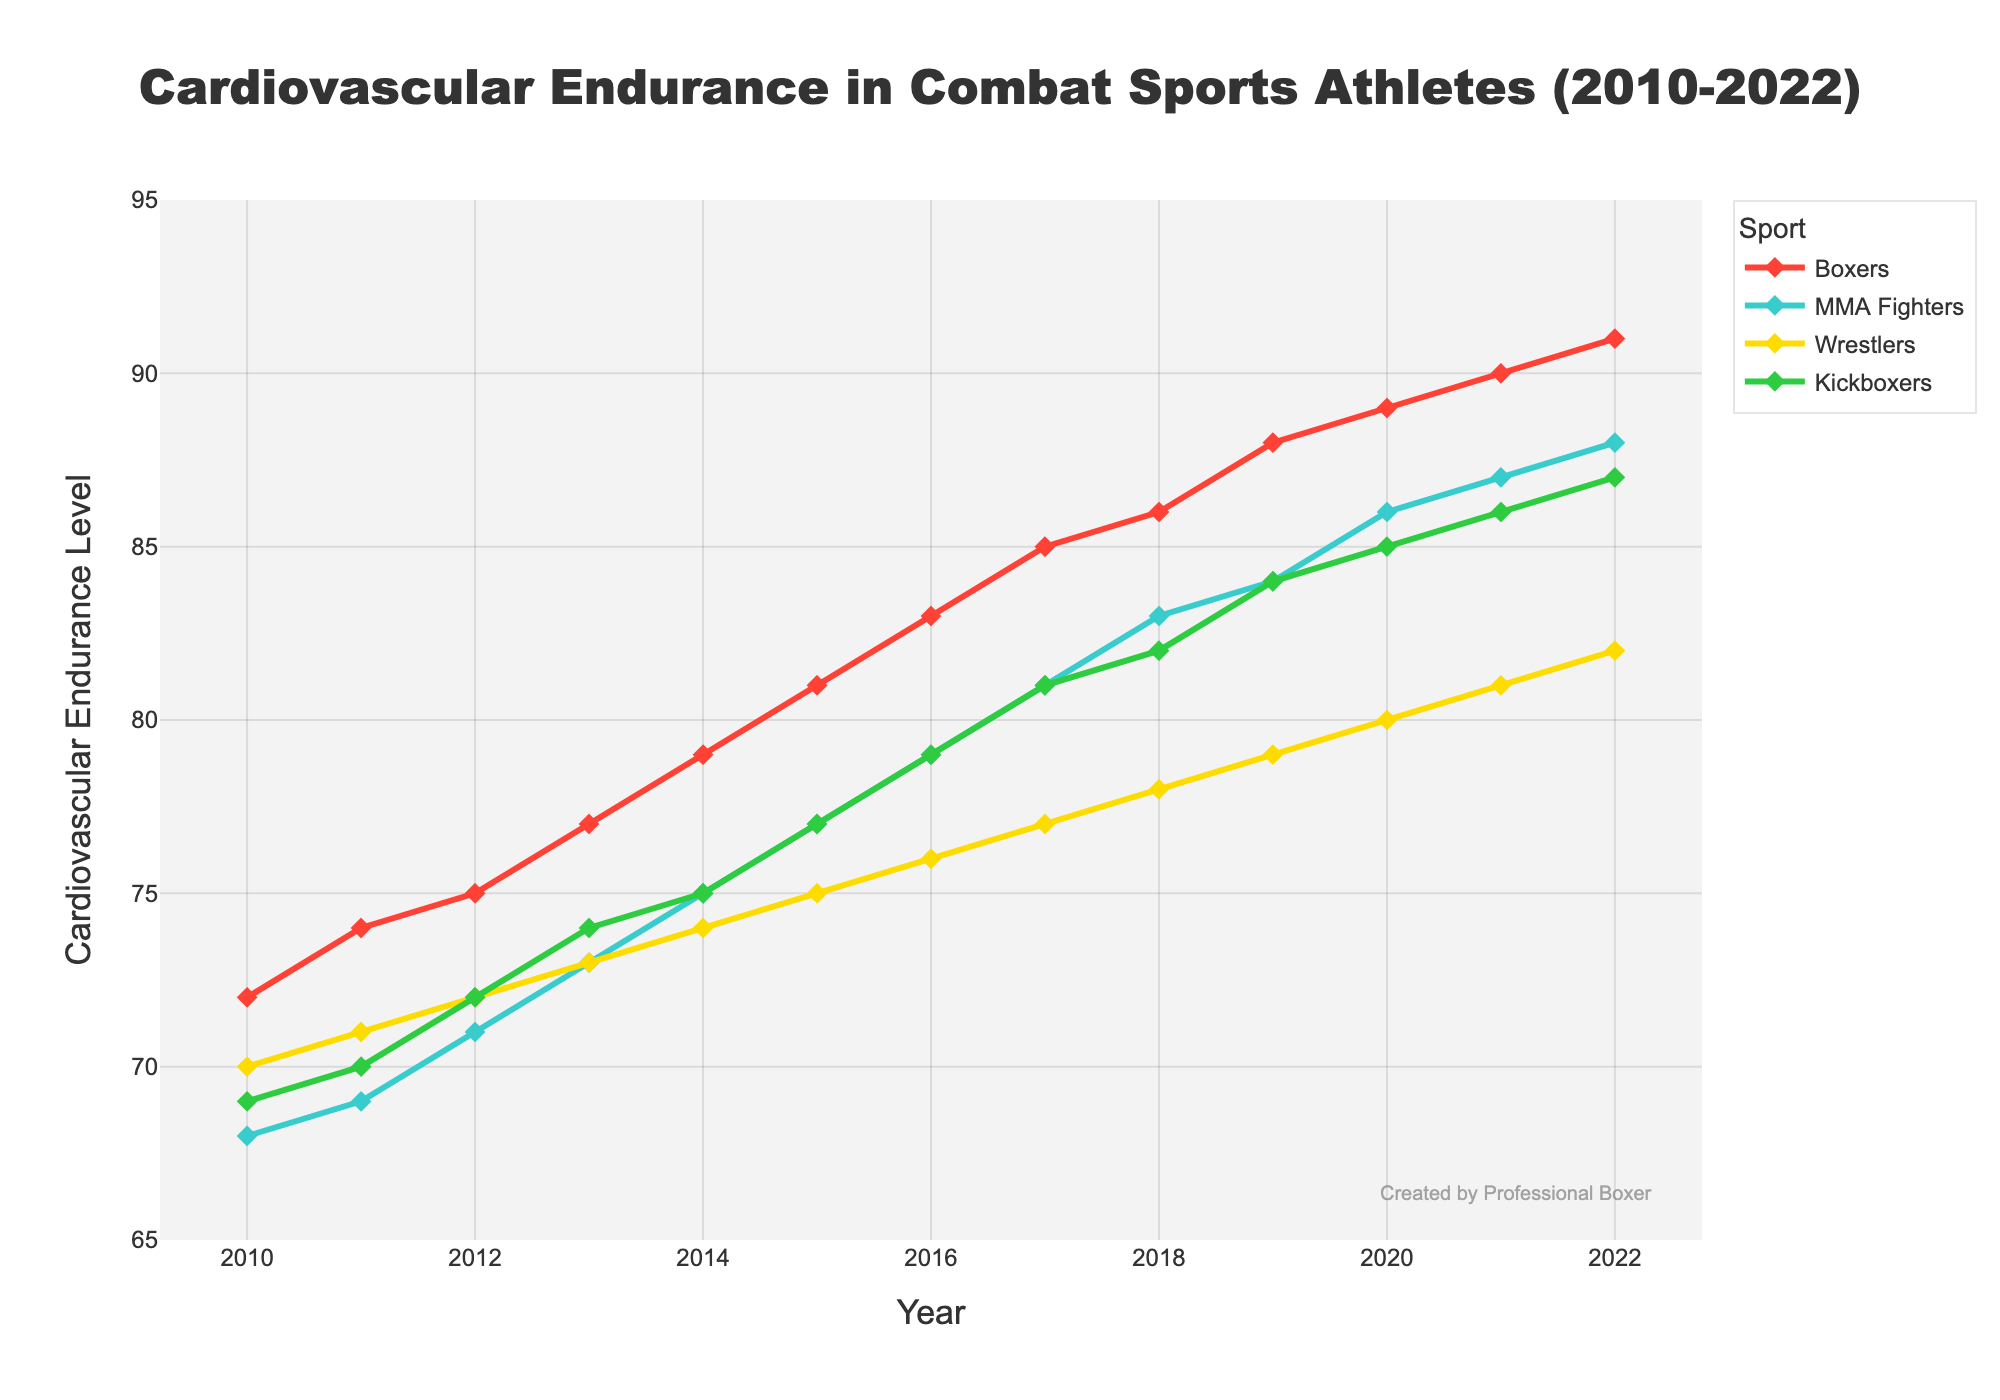Which sport has the highest cardiovascular endurance level in 2022? By looking at the figure, the trace representing Boxers reaches the highest peak at 2022 with a value of 91 compared to other sports.
Answer: Boxers How does the cardiovascular endurance level of MMA Fighters in 2015 compare to Kickboxers in the same year? In the figure, the mark for MMA Fighters in 2015 is at 77, while Kickboxers are at 77. Both values are equal.
Answer: Equal What is the difference in cardiovascular endurance levels between Boxers and Wrestlers in 2020? From the 2020 data points, Boxers are at a level of 89, and Wrestlers are at 80. The difference between them is 89 - 80 = 9.
Answer: 9 Which sport has shown the largest increase in cardiovascular endurance levels from 2010 to 2022? By comparing the starting point (2010) and ending point (2022) of each trace, Boxers went from 72 to 91, increasing by 19 points, the largest among all the sports.
Answer: Boxers On average, how did the cardiovascular endurance levels of Kickboxers change from 2010 to 2022? Averaging the cardiovascular endurance levels of Kickboxers from 2010 to 2022: (69 + 70 + 72 + 74 + 75 + 77 + 79 + 81 + 82 + 84 + 85 + 86 + 87) / 13 = 78.4. The change is from 69 to 87, thus an increase of 87 - 69 = 18.
Answer: Increased by 18 Which years did Boxers and Wrestlers have the exact same cardiovascular endurance level? By examining the line intersections and points, in 2012, Boxers were at 75 and Wrestlers at 75, which do not match; so there are no years where Boxers and Wrestlers had the exact same level across this period.
Answer: None What is the average cardiovascular endurance level of MMA Fighters from 2010 to 2012? Summing the values for MMA Fighters from 2010-2012 and dividing by 3 gives (68 + 69 + 71) / 3 = 69.33.
Answer: 69.33 During which period did Kickboxers show the largest yearly increase in cardiovascular endurance? Comparing year-to-year increases for Kickboxers, between 2011 and 2012, there's the largest gain of 72 - 70 = 2 units.
Answer: 2011 to 2012 Which year saw the smallest difference in cardiovascular endurance levels between MMA Fighters and Wrestlers? Observing yearly differences, in 2020 MMA Fighters and Wrestlers differed by 6 (86 - 80 = 6), which is the smallest difference across all years.
Answer: 2020 